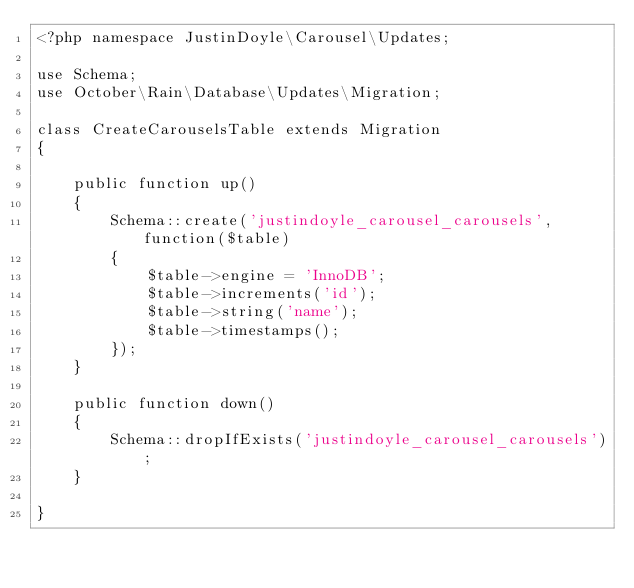<code> <loc_0><loc_0><loc_500><loc_500><_PHP_><?php namespace JustinDoyle\Carousel\Updates;

use Schema;
use October\Rain\Database\Updates\Migration;

class CreateCarouselsTable extends Migration
{

    public function up()
    {
        Schema::create('justindoyle_carousel_carousels', function($table)
        {
            $table->engine = 'InnoDB';
            $table->increments('id');
            $table->string('name');
            $table->timestamps();
        });
    }

    public function down()
    {
        Schema::dropIfExists('justindoyle_carousel_carousels');
    }

}
</code> 